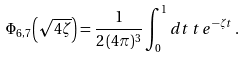Convert formula to latex. <formula><loc_0><loc_0><loc_500><loc_500>\Phi _ { 6 , 7 } { \left ( \sqrt { 4 \zeta } \right ) } = \frac { 1 } { 2 \, ( 4 \pi ) ^ { 3 } } \int _ { 0 } ^ { 1 } d t \, t \, e ^ { - \zeta t } \, .</formula> 